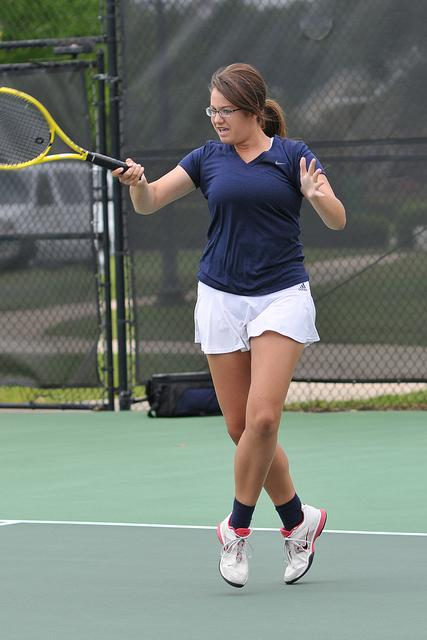What brand skirt she worn?

Choices:
A) adidas
B) nike
C) asics
D) puma adidas 